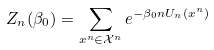<formula> <loc_0><loc_0><loc_500><loc_500>Z _ { n } ( \beta _ { 0 } ) = \sum _ { x ^ { n } \in \mathcal { X } ^ { n } } e ^ { - \beta _ { 0 } n U _ { n } ( x ^ { n } ) }</formula> 